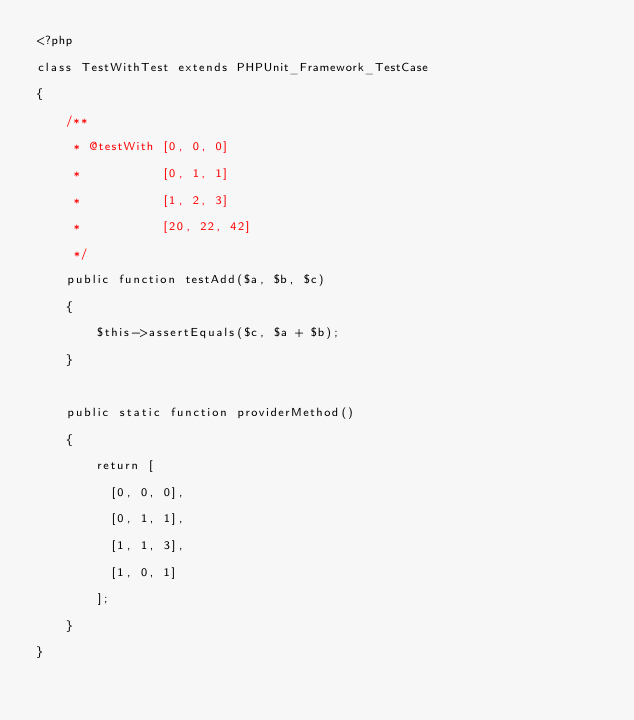Convert code to text. <code><loc_0><loc_0><loc_500><loc_500><_PHP_><?php
class TestWithTest extends PHPUnit_Framework_TestCase
{
    /**
     * @testWith [0, 0, 0]
     *           [0, 1, 1]
     *           [1, 2, 3]
     *           [20, 22, 42]
     */
    public function testAdd($a, $b, $c)
    {
        $this->assertEquals($c, $a + $b);
    }

    public static function providerMethod()
    {
        return [
          [0, 0, 0],
          [0, 1, 1],
          [1, 1, 3],
          [1, 0, 1]
        ];
    }
}
</code> 